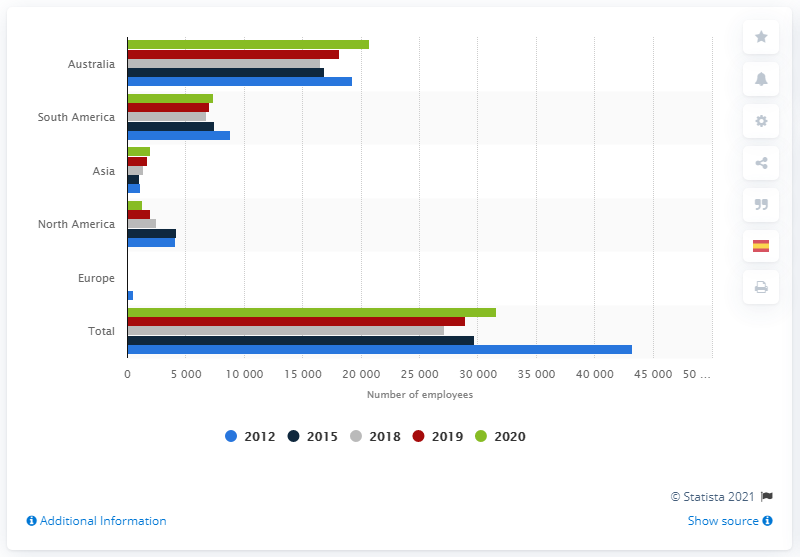Identify some key points in this picture. According to the data, the second-largest share of BHP employees resided in South America. 